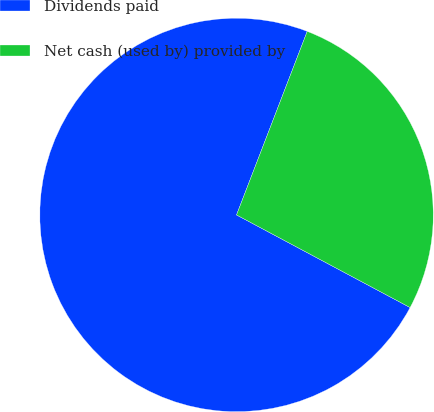Convert chart to OTSL. <chart><loc_0><loc_0><loc_500><loc_500><pie_chart><fcel>Dividends paid<fcel>Net cash (used by) provided by<nl><fcel>73.05%<fcel>26.95%<nl></chart> 